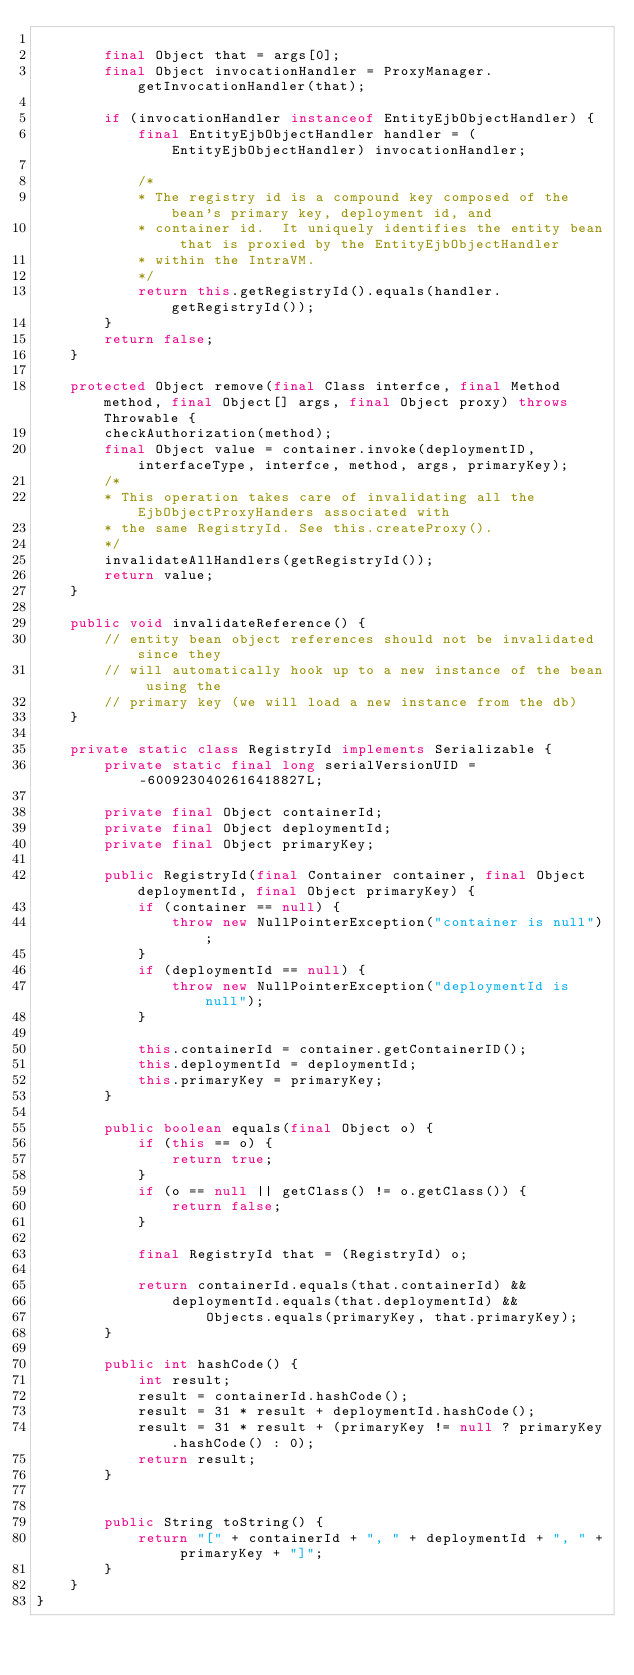<code> <loc_0><loc_0><loc_500><loc_500><_Java_>
        final Object that = args[0];
        final Object invocationHandler = ProxyManager.getInvocationHandler(that);

        if (invocationHandler instanceof EntityEjbObjectHandler) {
            final EntityEjbObjectHandler handler = (EntityEjbObjectHandler) invocationHandler;

            /*
            * The registry id is a compound key composed of the bean's primary key, deployment id, and
            * container id.  It uniquely identifies the entity bean that is proxied by the EntityEjbObjectHandler
            * within the IntraVM.
            */
            return this.getRegistryId().equals(handler.getRegistryId());
        }
        return false;
    }

    protected Object remove(final Class interfce, final Method method, final Object[] args, final Object proxy) throws Throwable {
        checkAuthorization(method);
        final Object value = container.invoke(deploymentID, interfaceType, interfce, method, args, primaryKey);
        /* 
        * This operation takes care of invalidating all the EjbObjectProxyHanders associated with 
        * the same RegistryId. See this.createProxy().
        */
        invalidateAllHandlers(getRegistryId());
        return value;
    }

    public void invalidateReference() {
        // entity bean object references should not be invalidated since they
        // will automatically hook up to a new instance of the bean using the
        // primary key (we will load a new instance from the db)
    }

    private static class RegistryId implements Serializable {
        private static final long serialVersionUID = -6009230402616418827L;

        private final Object containerId;
        private final Object deploymentId;
        private final Object primaryKey;

        public RegistryId(final Container container, final Object deploymentId, final Object primaryKey) {
            if (container == null) {
                throw new NullPointerException("container is null");
            }
            if (deploymentId == null) {
                throw new NullPointerException("deploymentId is null");
            }

            this.containerId = container.getContainerID();
            this.deploymentId = deploymentId;
            this.primaryKey = primaryKey;
        }

        public boolean equals(final Object o) {
            if (this == o) {
                return true;
            }
            if (o == null || getClass() != o.getClass()) {
                return false;
            }

            final RegistryId that = (RegistryId) o;

            return containerId.equals(that.containerId) &&
                deploymentId.equals(that.deploymentId) &&
                    Objects.equals(primaryKey, that.primaryKey);
        }

        public int hashCode() {
            int result;
            result = containerId.hashCode();
            result = 31 * result + deploymentId.hashCode();
            result = 31 * result + (primaryKey != null ? primaryKey.hashCode() : 0);
            return result;
        }


        public String toString() {
            return "[" + containerId + ", " + deploymentId + ", " + primaryKey + "]";
        }
    }
}
</code> 